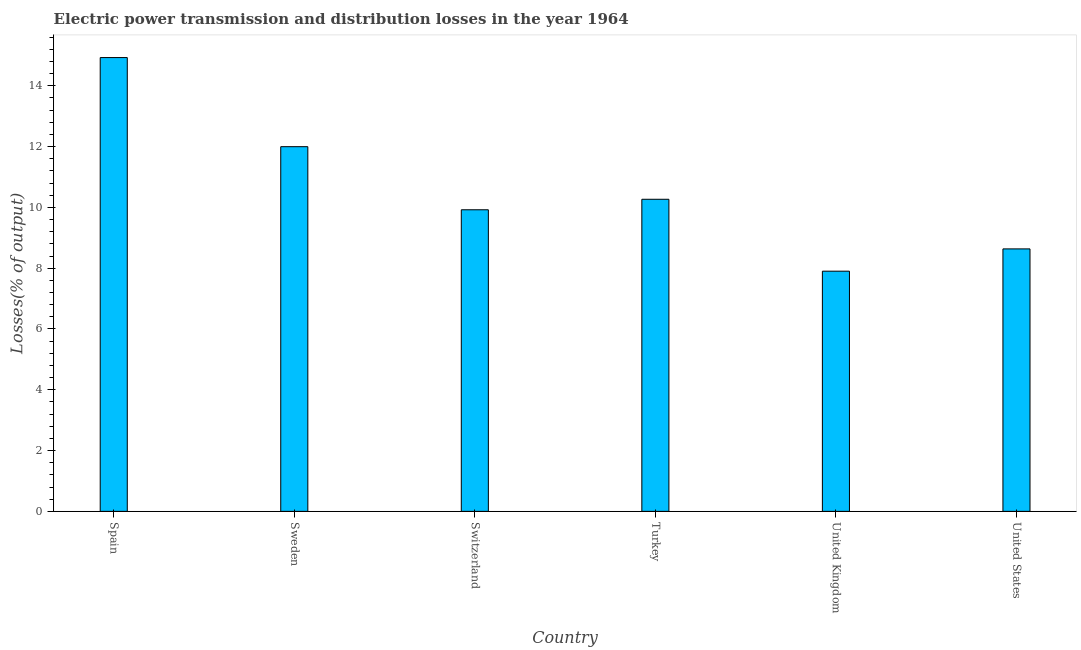Does the graph contain any zero values?
Make the answer very short. No. Does the graph contain grids?
Offer a terse response. No. What is the title of the graph?
Your response must be concise. Electric power transmission and distribution losses in the year 1964. What is the label or title of the Y-axis?
Keep it short and to the point. Losses(% of output). What is the electric power transmission and distribution losses in Spain?
Provide a succinct answer. 14.93. Across all countries, what is the maximum electric power transmission and distribution losses?
Keep it short and to the point. 14.93. Across all countries, what is the minimum electric power transmission and distribution losses?
Give a very brief answer. 7.9. In which country was the electric power transmission and distribution losses maximum?
Give a very brief answer. Spain. What is the sum of the electric power transmission and distribution losses?
Make the answer very short. 63.65. What is the difference between the electric power transmission and distribution losses in Spain and Sweden?
Your response must be concise. 2.93. What is the average electric power transmission and distribution losses per country?
Your response must be concise. 10.61. What is the median electric power transmission and distribution losses?
Give a very brief answer. 10.09. In how many countries, is the electric power transmission and distribution losses greater than 12 %?
Make the answer very short. 1. Is the electric power transmission and distribution losses in Spain less than that in Turkey?
Your answer should be very brief. No. Is the difference between the electric power transmission and distribution losses in Switzerland and United States greater than the difference between any two countries?
Offer a terse response. No. What is the difference between the highest and the second highest electric power transmission and distribution losses?
Provide a short and direct response. 2.93. What is the difference between the highest and the lowest electric power transmission and distribution losses?
Give a very brief answer. 7.03. How many countries are there in the graph?
Provide a succinct answer. 6. What is the difference between two consecutive major ticks on the Y-axis?
Provide a short and direct response. 2. What is the Losses(% of output) in Spain?
Give a very brief answer. 14.93. What is the Losses(% of output) in Sweden?
Your answer should be very brief. 12. What is the Losses(% of output) of Switzerland?
Your answer should be compact. 9.92. What is the Losses(% of output) of Turkey?
Make the answer very short. 10.27. What is the Losses(% of output) in United Kingdom?
Your response must be concise. 7.9. What is the Losses(% of output) of United States?
Make the answer very short. 8.63. What is the difference between the Losses(% of output) in Spain and Sweden?
Your answer should be compact. 2.93. What is the difference between the Losses(% of output) in Spain and Switzerland?
Provide a succinct answer. 5.01. What is the difference between the Losses(% of output) in Spain and Turkey?
Give a very brief answer. 4.66. What is the difference between the Losses(% of output) in Spain and United Kingdom?
Give a very brief answer. 7.03. What is the difference between the Losses(% of output) in Spain and United States?
Ensure brevity in your answer.  6.29. What is the difference between the Losses(% of output) in Sweden and Switzerland?
Your answer should be compact. 2.08. What is the difference between the Losses(% of output) in Sweden and Turkey?
Give a very brief answer. 1.73. What is the difference between the Losses(% of output) in Sweden and United Kingdom?
Provide a short and direct response. 4.1. What is the difference between the Losses(% of output) in Sweden and United States?
Offer a terse response. 3.36. What is the difference between the Losses(% of output) in Switzerland and Turkey?
Offer a terse response. -0.35. What is the difference between the Losses(% of output) in Switzerland and United Kingdom?
Keep it short and to the point. 2.02. What is the difference between the Losses(% of output) in Switzerland and United States?
Provide a succinct answer. 1.29. What is the difference between the Losses(% of output) in Turkey and United Kingdom?
Offer a very short reply. 2.37. What is the difference between the Losses(% of output) in Turkey and United States?
Offer a very short reply. 1.63. What is the difference between the Losses(% of output) in United Kingdom and United States?
Ensure brevity in your answer.  -0.73. What is the ratio of the Losses(% of output) in Spain to that in Sweden?
Ensure brevity in your answer.  1.24. What is the ratio of the Losses(% of output) in Spain to that in Switzerland?
Ensure brevity in your answer.  1.5. What is the ratio of the Losses(% of output) in Spain to that in Turkey?
Your answer should be very brief. 1.45. What is the ratio of the Losses(% of output) in Spain to that in United Kingdom?
Ensure brevity in your answer.  1.89. What is the ratio of the Losses(% of output) in Spain to that in United States?
Your response must be concise. 1.73. What is the ratio of the Losses(% of output) in Sweden to that in Switzerland?
Your response must be concise. 1.21. What is the ratio of the Losses(% of output) in Sweden to that in Turkey?
Offer a very short reply. 1.17. What is the ratio of the Losses(% of output) in Sweden to that in United Kingdom?
Your answer should be compact. 1.52. What is the ratio of the Losses(% of output) in Sweden to that in United States?
Your answer should be compact. 1.39. What is the ratio of the Losses(% of output) in Switzerland to that in United Kingdom?
Offer a terse response. 1.26. What is the ratio of the Losses(% of output) in Switzerland to that in United States?
Give a very brief answer. 1.15. What is the ratio of the Losses(% of output) in Turkey to that in United Kingdom?
Your response must be concise. 1.3. What is the ratio of the Losses(% of output) in Turkey to that in United States?
Provide a short and direct response. 1.19. What is the ratio of the Losses(% of output) in United Kingdom to that in United States?
Keep it short and to the point. 0.92. 